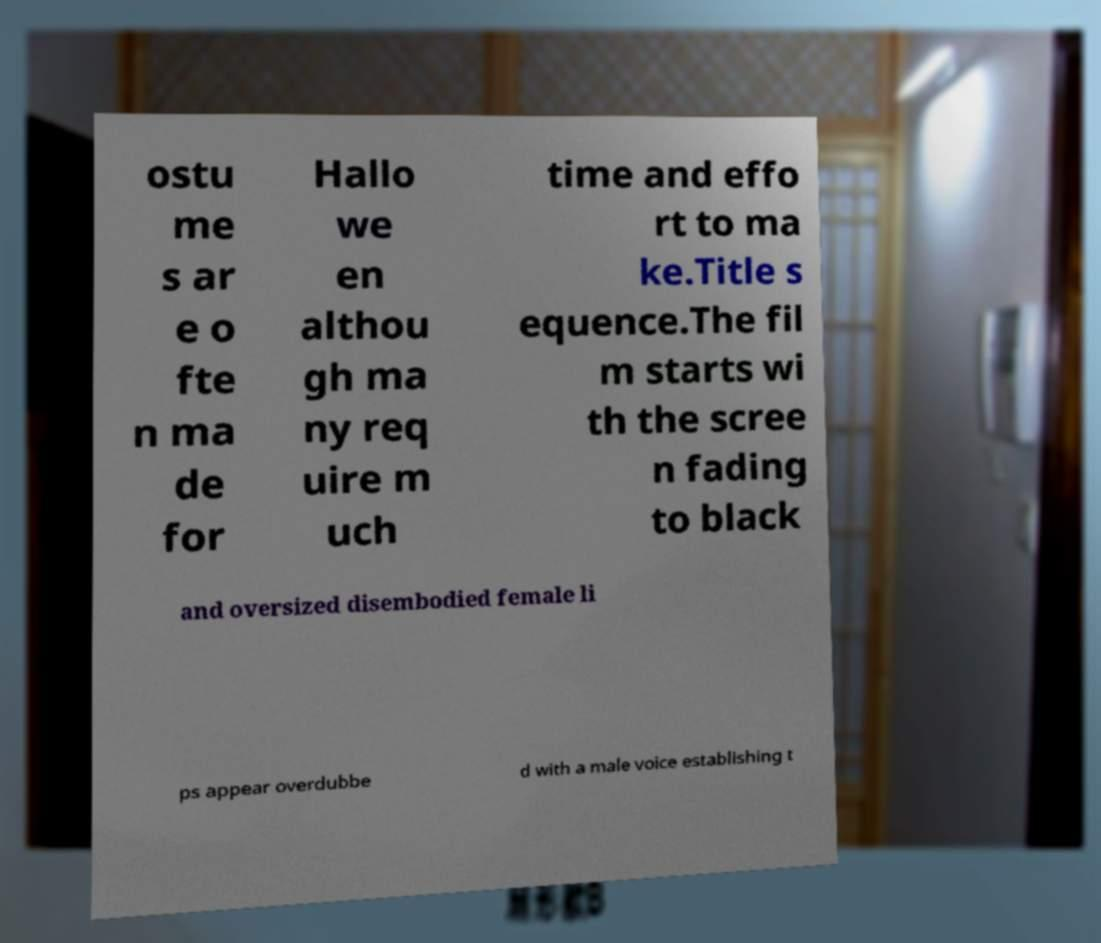I need the written content from this picture converted into text. Can you do that? ostu me s ar e o fte n ma de for Hallo we en althou gh ma ny req uire m uch time and effo rt to ma ke.Title s equence.The fil m starts wi th the scree n fading to black and oversized disembodied female li ps appear overdubbe d with a male voice establishing t 